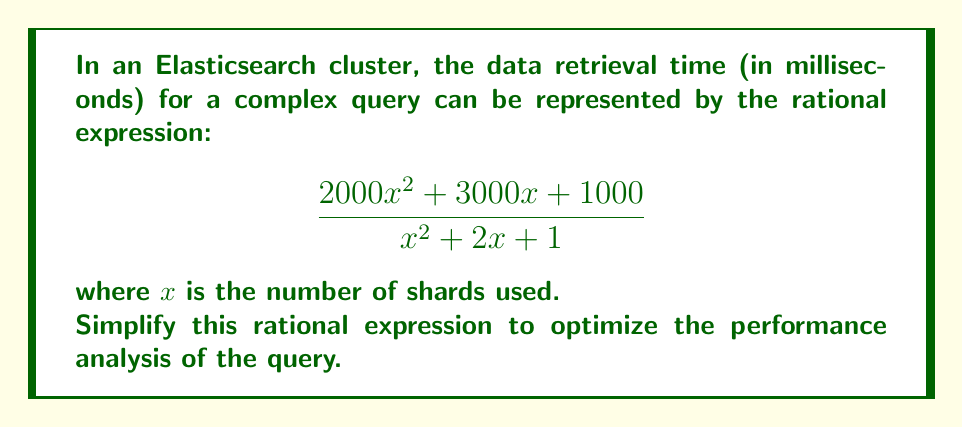Can you solve this math problem? Let's simplify this rational expression step by step:

1) First, we can factor out the greatest common factor (GCF) from the numerator:
   $$\frac{1000(2x^2 + 3x + 1)}{x^2 + 2x + 1}$$

2) Now, let's focus on the numerator and denominator separately:
   
   Numerator: $1000(2x^2 + 3x + 1)$
   Denominator: $x^2 + 2x + 1$

3) We can recognize that the denominator is a perfect square trinomial:
   $x^2 + 2x + 1 = (x + 1)^2$

4) For the numerator, we can try to factor it:
   $2x^2 + 3x + 1 = (2x + 1)(x + 1)$

5) Now our expression looks like:
   $$\frac{1000(2x + 1)(x + 1)}{(x + 1)^2}$$

6) We can cancel out one $(x + 1)$ term from the numerator and denominator:
   $$\frac{1000(2x + 1)}{x + 1}$$

7) This is the simplified form of the rational expression.
Answer: $$\frac{1000(2x + 1)}{x + 1}$$ 